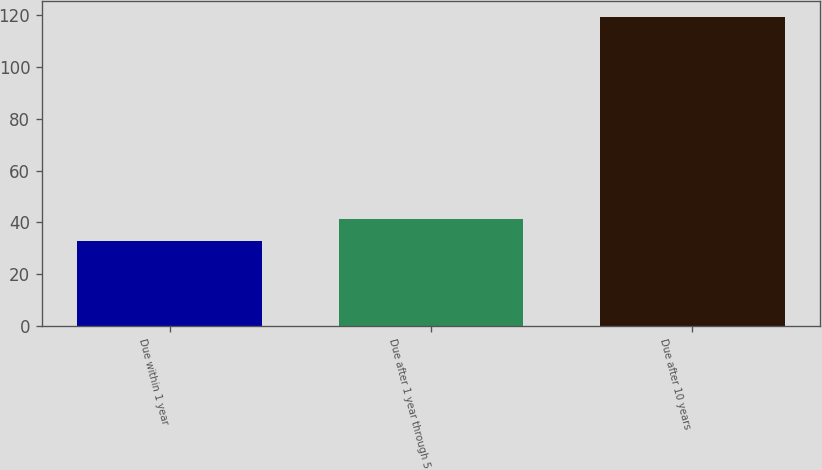Convert chart. <chart><loc_0><loc_0><loc_500><loc_500><bar_chart><fcel>Due within 1 year<fcel>Due after 1 year through 5<fcel>Due after 10 years<nl><fcel>32.8<fcel>41.46<fcel>119.4<nl></chart> 